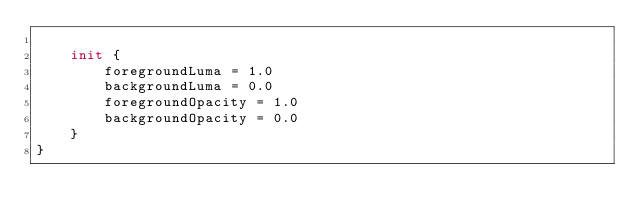Convert code to text. <code><loc_0><loc_0><loc_500><loc_500><_Kotlin_>
    init {
        foregroundLuma = 1.0
        backgroundLuma = 0.0
        foregroundOpacity = 1.0
        backgroundOpacity = 0.0
    }
}</code> 